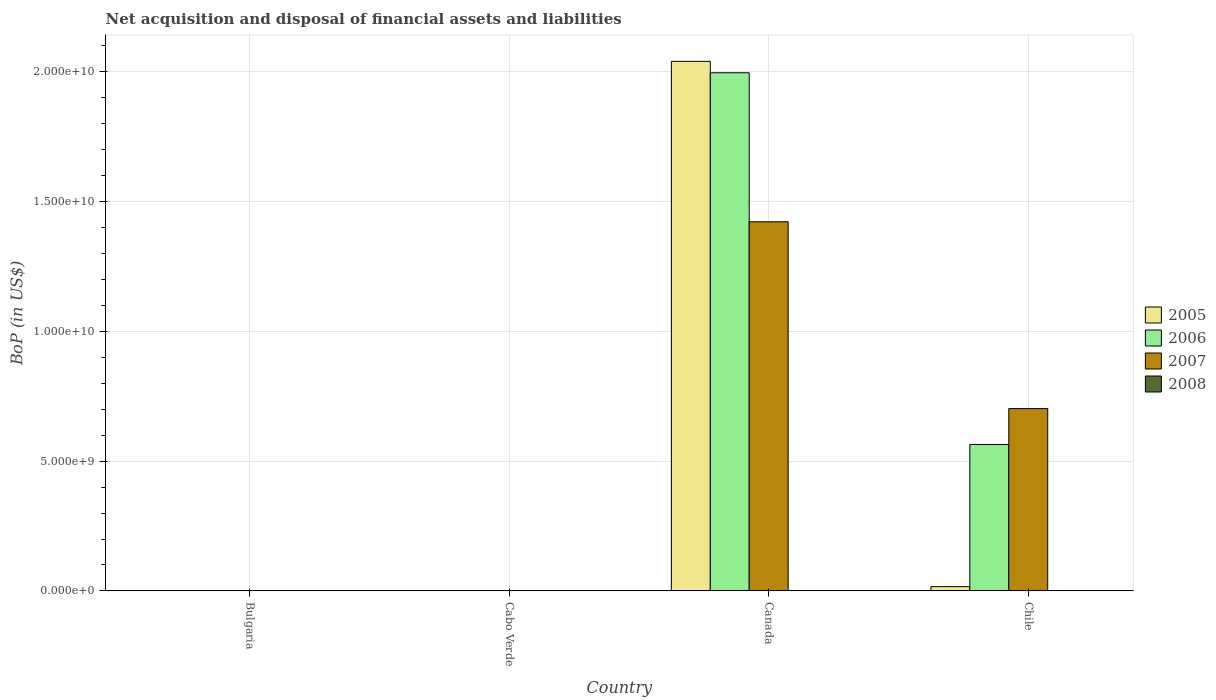How many different coloured bars are there?
Offer a terse response. 3. Are the number of bars per tick equal to the number of legend labels?
Give a very brief answer. No. How many bars are there on the 2nd tick from the left?
Ensure brevity in your answer.  0. What is the Balance of Payments in 2007 in Chile?
Ensure brevity in your answer.  7.02e+09. Across all countries, what is the maximum Balance of Payments in 2007?
Offer a very short reply. 1.42e+1. In which country was the Balance of Payments in 2007 maximum?
Your response must be concise. Canada. What is the total Balance of Payments in 2006 in the graph?
Your answer should be compact. 2.56e+1. What is the difference between the Balance of Payments in 2007 in Canada and that in Chile?
Provide a succinct answer. 7.19e+09. What is the average Balance of Payments in 2006 per country?
Your response must be concise. 6.40e+09. What is the difference between the Balance of Payments of/in 2007 and Balance of Payments of/in 2005 in Canada?
Provide a succinct answer. -6.18e+09. What is the ratio of the Balance of Payments in 2005 in Canada to that in Chile?
Your answer should be very brief. 122.81. Is the difference between the Balance of Payments in 2007 in Canada and Chile greater than the difference between the Balance of Payments in 2005 in Canada and Chile?
Ensure brevity in your answer.  No. What is the difference between the highest and the lowest Balance of Payments in 2006?
Offer a terse response. 2.00e+1. In how many countries, is the Balance of Payments in 2008 greater than the average Balance of Payments in 2008 taken over all countries?
Your answer should be very brief. 0. Is it the case that in every country, the sum of the Balance of Payments in 2005 and Balance of Payments in 2008 is greater than the Balance of Payments in 2007?
Your response must be concise. No. How many bars are there?
Provide a short and direct response. 6. What is the title of the graph?
Provide a succinct answer. Net acquisition and disposal of financial assets and liabilities. What is the label or title of the X-axis?
Keep it short and to the point. Country. What is the label or title of the Y-axis?
Your answer should be compact. BoP (in US$). What is the BoP (in US$) in 2005 in Bulgaria?
Offer a terse response. 0. What is the BoP (in US$) in 2006 in Bulgaria?
Your answer should be compact. 0. What is the BoP (in US$) of 2008 in Bulgaria?
Provide a short and direct response. 0. What is the BoP (in US$) of 2006 in Cabo Verde?
Make the answer very short. 0. What is the BoP (in US$) in 2005 in Canada?
Make the answer very short. 2.04e+1. What is the BoP (in US$) of 2006 in Canada?
Provide a succinct answer. 2.00e+1. What is the BoP (in US$) of 2007 in Canada?
Your answer should be compact. 1.42e+1. What is the BoP (in US$) in 2008 in Canada?
Give a very brief answer. 0. What is the BoP (in US$) in 2005 in Chile?
Make the answer very short. 1.66e+08. What is the BoP (in US$) of 2006 in Chile?
Your response must be concise. 5.64e+09. What is the BoP (in US$) of 2007 in Chile?
Your answer should be compact. 7.02e+09. What is the BoP (in US$) in 2008 in Chile?
Provide a succinct answer. 0. Across all countries, what is the maximum BoP (in US$) of 2005?
Make the answer very short. 2.04e+1. Across all countries, what is the maximum BoP (in US$) of 2006?
Keep it short and to the point. 2.00e+1. Across all countries, what is the maximum BoP (in US$) in 2007?
Make the answer very short. 1.42e+1. Across all countries, what is the minimum BoP (in US$) in 2005?
Ensure brevity in your answer.  0. What is the total BoP (in US$) in 2005 in the graph?
Make the answer very short. 2.06e+1. What is the total BoP (in US$) in 2006 in the graph?
Provide a short and direct response. 2.56e+1. What is the total BoP (in US$) in 2007 in the graph?
Provide a succinct answer. 2.12e+1. What is the difference between the BoP (in US$) of 2005 in Canada and that in Chile?
Make the answer very short. 2.02e+1. What is the difference between the BoP (in US$) in 2006 in Canada and that in Chile?
Ensure brevity in your answer.  1.43e+1. What is the difference between the BoP (in US$) in 2007 in Canada and that in Chile?
Your response must be concise. 7.19e+09. What is the difference between the BoP (in US$) of 2005 in Canada and the BoP (in US$) of 2006 in Chile?
Offer a very short reply. 1.48e+1. What is the difference between the BoP (in US$) in 2005 in Canada and the BoP (in US$) in 2007 in Chile?
Provide a succinct answer. 1.34e+1. What is the difference between the BoP (in US$) in 2006 in Canada and the BoP (in US$) in 2007 in Chile?
Your answer should be compact. 1.29e+1. What is the average BoP (in US$) of 2005 per country?
Ensure brevity in your answer.  5.14e+09. What is the average BoP (in US$) of 2006 per country?
Your answer should be very brief. 6.40e+09. What is the average BoP (in US$) in 2007 per country?
Ensure brevity in your answer.  5.31e+09. What is the average BoP (in US$) of 2008 per country?
Your response must be concise. 0. What is the difference between the BoP (in US$) of 2005 and BoP (in US$) of 2006 in Canada?
Your answer should be compact. 4.40e+08. What is the difference between the BoP (in US$) in 2005 and BoP (in US$) in 2007 in Canada?
Provide a succinct answer. 6.18e+09. What is the difference between the BoP (in US$) in 2006 and BoP (in US$) in 2007 in Canada?
Your response must be concise. 5.74e+09. What is the difference between the BoP (in US$) in 2005 and BoP (in US$) in 2006 in Chile?
Provide a short and direct response. -5.48e+09. What is the difference between the BoP (in US$) of 2005 and BoP (in US$) of 2007 in Chile?
Keep it short and to the point. -6.86e+09. What is the difference between the BoP (in US$) in 2006 and BoP (in US$) in 2007 in Chile?
Give a very brief answer. -1.38e+09. What is the ratio of the BoP (in US$) in 2005 in Canada to that in Chile?
Offer a terse response. 122.81. What is the ratio of the BoP (in US$) in 2006 in Canada to that in Chile?
Provide a short and direct response. 3.54. What is the ratio of the BoP (in US$) of 2007 in Canada to that in Chile?
Your answer should be compact. 2.02. What is the difference between the highest and the lowest BoP (in US$) of 2005?
Ensure brevity in your answer.  2.04e+1. What is the difference between the highest and the lowest BoP (in US$) in 2006?
Your answer should be very brief. 2.00e+1. What is the difference between the highest and the lowest BoP (in US$) of 2007?
Make the answer very short. 1.42e+1. 